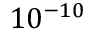Convert formula to latex. <formula><loc_0><loc_0><loc_500><loc_500>1 0 ^ { - 1 0 }</formula> 